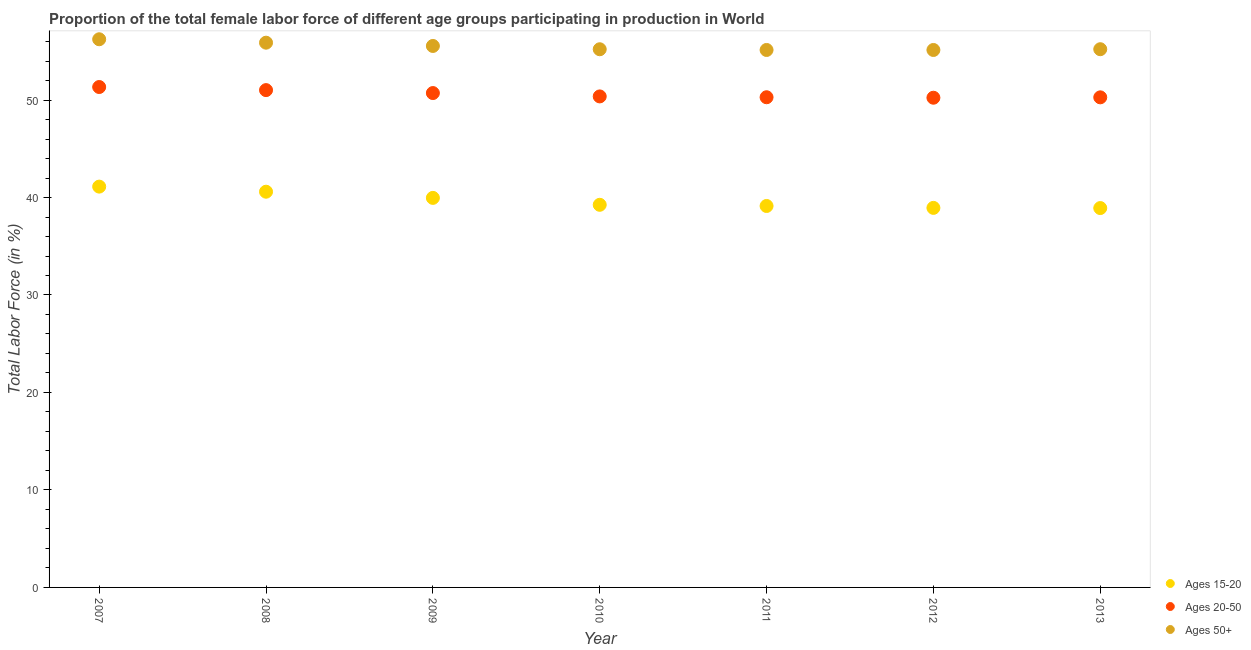How many different coloured dotlines are there?
Give a very brief answer. 3. What is the percentage of female labor force within the age group 20-50 in 2011?
Provide a succinct answer. 50.29. Across all years, what is the maximum percentage of female labor force within the age group 20-50?
Your answer should be very brief. 51.34. Across all years, what is the minimum percentage of female labor force within the age group 15-20?
Give a very brief answer. 38.92. What is the total percentage of female labor force above age 50 in the graph?
Give a very brief answer. 388.36. What is the difference between the percentage of female labor force within the age group 20-50 in 2007 and that in 2013?
Your response must be concise. 1.06. What is the difference between the percentage of female labor force within the age group 20-50 in 2011 and the percentage of female labor force above age 50 in 2008?
Keep it short and to the point. -5.6. What is the average percentage of female labor force within the age group 20-50 per year?
Provide a short and direct response. 50.61. In the year 2010, what is the difference between the percentage of female labor force within the age group 20-50 and percentage of female labor force above age 50?
Provide a short and direct response. -4.84. What is the ratio of the percentage of female labor force within the age group 15-20 in 2007 to that in 2011?
Your answer should be very brief. 1.05. What is the difference between the highest and the second highest percentage of female labor force above age 50?
Offer a very short reply. 0.35. What is the difference between the highest and the lowest percentage of female labor force above age 50?
Your answer should be very brief. 1.1. In how many years, is the percentage of female labor force above age 50 greater than the average percentage of female labor force above age 50 taken over all years?
Keep it short and to the point. 3. Is it the case that in every year, the sum of the percentage of female labor force within the age group 15-20 and percentage of female labor force within the age group 20-50 is greater than the percentage of female labor force above age 50?
Provide a succinct answer. Yes. Does the percentage of female labor force within the age group 15-20 monotonically increase over the years?
Offer a very short reply. No. Is the percentage of female labor force within the age group 20-50 strictly less than the percentage of female labor force above age 50 over the years?
Make the answer very short. Yes. How many years are there in the graph?
Ensure brevity in your answer.  7. What is the difference between two consecutive major ticks on the Y-axis?
Keep it short and to the point. 10. Where does the legend appear in the graph?
Your answer should be very brief. Bottom right. How many legend labels are there?
Your response must be concise. 3. What is the title of the graph?
Make the answer very short. Proportion of the total female labor force of different age groups participating in production in World. Does "Fuel" appear as one of the legend labels in the graph?
Provide a short and direct response. No. What is the label or title of the X-axis?
Your answer should be compact. Year. What is the Total Labor Force (in %) of Ages 15-20 in 2007?
Keep it short and to the point. 41.12. What is the Total Labor Force (in %) of Ages 20-50 in 2007?
Offer a terse response. 51.34. What is the Total Labor Force (in %) of Ages 50+ in 2007?
Keep it short and to the point. 56.23. What is the Total Labor Force (in %) of Ages 15-20 in 2008?
Ensure brevity in your answer.  40.59. What is the Total Labor Force (in %) in Ages 20-50 in 2008?
Offer a terse response. 51.02. What is the Total Labor Force (in %) in Ages 50+ in 2008?
Provide a succinct answer. 55.88. What is the Total Labor Force (in %) of Ages 15-20 in 2009?
Provide a succinct answer. 39.96. What is the Total Labor Force (in %) of Ages 20-50 in 2009?
Give a very brief answer. 50.72. What is the Total Labor Force (in %) in Ages 50+ in 2009?
Make the answer very short. 55.55. What is the Total Labor Force (in %) in Ages 15-20 in 2010?
Your answer should be compact. 39.25. What is the Total Labor Force (in %) of Ages 20-50 in 2010?
Provide a short and direct response. 50.37. What is the Total Labor Force (in %) in Ages 50+ in 2010?
Ensure brevity in your answer.  55.21. What is the Total Labor Force (in %) of Ages 15-20 in 2011?
Offer a very short reply. 39.13. What is the Total Labor Force (in %) of Ages 20-50 in 2011?
Offer a very short reply. 50.29. What is the Total Labor Force (in %) in Ages 50+ in 2011?
Provide a succinct answer. 55.14. What is the Total Labor Force (in %) in Ages 15-20 in 2012?
Provide a short and direct response. 38.94. What is the Total Labor Force (in %) of Ages 20-50 in 2012?
Offer a very short reply. 50.24. What is the Total Labor Force (in %) in Ages 50+ in 2012?
Offer a very short reply. 55.14. What is the Total Labor Force (in %) in Ages 15-20 in 2013?
Provide a short and direct response. 38.92. What is the Total Labor Force (in %) in Ages 20-50 in 2013?
Your answer should be very brief. 50.28. What is the Total Labor Force (in %) in Ages 50+ in 2013?
Give a very brief answer. 55.21. Across all years, what is the maximum Total Labor Force (in %) in Ages 15-20?
Give a very brief answer. 41.12. Across all years, what is the maximum Total Labor Force (in %) in Ages 20-50?
Offer a very short reply. 51.34. Across all years, what is the maximum Total Labor Force (in %) in Ages 50+?
Ensure brevity in your answer.  56.23. Across all years, what is the minimum Total Labor Force (in %) of Ages 15-20?
Keep it short and to the point. 38.92. Across all years, what is the minimum Total Labor Force (in %) of Ages 20-50?
Your answer should be compact. 50.24. Across all years, what is the minimum Total Labor Force (in %) in Ages 50+?
Keep it short and to the point. 55.14. What is the total Total Labor Force (in %) of Ages 15-20 in the graph?
Ensure brevity in your answer.  277.91. What is the total Total Labor Force (in %) in Ages 20-50 in the graph?
Give a very brief answer. 354.24. What is the total Total Labor Force (in %) of Ages 50+ in the graph?
Your answer should be very brief. 388.36. What is the difference between the Total Labor Force (in %) in Ages 15-20 in 2007 and that in 2008?
Your answer should be compact. 0.52. What is the difference between the Total Labor Force (in %) of Ages 20-50 in 2007 and that in 2008?
Offer a terse response. 0.32. What is the difference between the Total Labor Force (in %) in Ages 50+ in 2007 and that in 2008?
Offer a terse response. 0.35. What is the difference between the Total Labor Force (in %) in Ages 15-20 in 2007 and that in 2009?
Offer a very short reply. 1.16. What is the difference between the Total Labor Force (in %) of Ages 20-50 in 2007 and that in 2009?
Offer a very short reply. 0.62. What is the difference between the Total Labor Force (in %) in Ages 50+ in 2007 and that in 2009?
Keep it short and to the point. 0.69. What is the difference between the Total Labor Force (in %) of Ages 15-20 in 2007 and that in 2010?
Keep it short and to the point. 1.87. What is the difference between the Total Labor Force (in %) in Ages 20-50 in 2007 and that in 2010?
Provide a succinct answer. 0.96. What is the difference between the Total Labor Force (in %) of Ages 50+ in 2007 and that in 2010?
Make the answer very short. 1.02. What is the difference between the Total Labor Force (in %) in Ages 15-20 in 2007 and that in 2011?
Keep it short and to the point. 1.99. What is the difference between the Total Labor Force (in %) in Ages 20-50 in 2007 and that in 2011?
Provide a short and direct response. 1.05. What is the difference between the Total Labor Force (in %) in Ages 50+ in 2007 and that in 2011?
Keep it short and to the point. 1.1. What is the difference between the Total Labor Force (in %) in Ages 15-20 in 2007 and that in 2012?
Offer a very short reply. 2.18. What is the difference between the Total Labor Force (in %) of Ages 20-50 in 2007 and that in 2012?
Provide a short and direct response. 1.1. What is the difference between the Total Labor Force (in %) in Ages 50+ in 2007 and that in 2012?
Your answer should be very brief. 1.1. What is the difference between the Total Labor Force (in %) of Ages 15-20 in 2007 and that in 2013?
Make the answer very short. 2.2. What is the difference between the Total Labor Force (in %) in Ages 20-50 in 2007 and that in 2013?
Your answer should be very brief. 1.06. What is the difference between the Total Labor Force (in %) of Ages 50+ in 2007 and that in 2013?
Ensure brevity in your answer.  1.02. What is the difference between the Total Labor Force (in %) in Ages 15-20 in 2008 and that in 2009?
Give a very brief answer. 0.63. What is the difference between the Total Labor Force (in %) in Ages 20-50 in 2008 and that in 2009?
Your answer should be compact. 0.3. What is the difference between the Total Labor Force (in %) of Ages 50+ in 2008 and that in 2009?
Keep it short and to the point. 0.34. What is the difference between the Total Labor Force (in %) of Ages 15-20 in 2008 and that in 2010?
Provide a short and direct response. 1.34. What is the difference between the Total Labor Force (in %) of Ages 20-50 in 2008 and that in 2010?
Keep it short and to the point. 0.65. What is the difference between the Total Labor Force (in %) of Ages 50+ in 2008 and that in 2010?
Your response must be concise. 0.67. What is the difference between the Total Labor Force (in %) in Ages 15-20 in 2008 and that in 2011?
Make the answer very short. 1.46. What is the difference between the Total Labor Force (in %) in Ages 20-50 in 2008 and that in 2011?
Provide a short and direct response. 0.73. What is the difference between the Total Labor Force (in %) in Ages 50+ in 2008 and that in 2011?
Provide a short and direct response. 0.75. What is the difference between the Total Labor Force (in %) of Ages 15-20 in 2008 and that in 2012?
Your answer should be compact. 1.66. What is the difference between the Total Labor Force (in %) in Ages 20-50 in 2008 and that in 2012?
Offer a terse response. 0.78. What is the difference between the Total Labor Force (in %) of Ages 50+ in 2008 and that in 2012?
Provide a short and direct response. 0.75. What is the difference between the Total Labor Force (in %) in Ages 15-20 in 2008 and that in 2013?
Provide a succinct answer. 1.68. What is the difference between the Total Labor Force (in %) in Ages 20-50 in 2008 and that in 2013?
Your answer should be compact. 0.74. What is the difference between the Total Labor Force (in %) of Ages 50+ in 2008 and that in 2013?
Offer a terse response. 0.67. What is the difference between the Total Labor Force (in %) in Ages 15-20 in 2009 and that in 2010?
Keep it short and to the point. 0.71. What is the difference between the Total Labor Force (in %) in Ages 20-50 in 2009 and that in 2010?
Your answer should be compact. 0.34. What is the difference between the Total Labor Force (in %) in Ages 50+ in 2009 and that in 2010?
Your answer should be compact. 0.34. What is the difference between the Total Labor Force (in %) of Ages 15-20 in 2009 and that in 2011?
Your answer should be compact. 0.83. What is the difference between the Total Labor Force (in %) in Ages 20-50 in 2009 and that in 2011?
Offer a very short reply. 0.43. What is the difference between the Total Labor Force (in %) of Ages 50+ in 2009 and that in 2011?
Your response must be concise. 0.41. What is the difference between the Total Labor Force (in %) in Ages 15-20 in 2009 and that in 2012?
Offer a very short reply. 1.03. What is the difference between the Total Labor Force (in %) in Ages 20-50 in 2009 and that in 2012?
Offer a terse response. 0.48. What is the difference between the Total Labor Force (in %) in Ages 50+ in 2009 and that in 2012?
Your answer should be very brief. 0.41. What is the difference between the Total Labor Force (in %) in Ages 15-20 in 2009 and that in 2013?
Provide a short and direct response. 1.04. What is the difference between the Total Labor Force (in %) in Ages 20-50 in 2009 and that in 2013?
Keep it short and to the point. 0.44. What is the difference between the Total Labor Force (in %) of Ages 15-20 in 2010 and that in 2011?
Give a very brief answer. 0.12. What is the difference between the Total Labor Force (in %) in Ages 20-50 in 2010 and that in 2011?
Make the answer very short. 0.09. What is the difference between the Total Labor Force (in %) of Ages 50+ in 2010 and that in 2011?
Offer a very short reply. 0.07. What is the difference between the Total Labor Force (in %) in Ages 15-20 in 2010 and that in 2012?
Keep it short and to the point. 0.32. What is the difference between the Total Labor Force (in %) of Ages 20-50 in 2010 and that in 2012?
Your answer should be very brief. 0.13. What is the difference between the Total Labor Force (in %) of Ages 50+ in 2010 and that in 2012?
Offer a terse response. 0.07. What is the difference between the Total Labor Force (in %) of Ages 15-20 in 2010 and that in 2013?
Offer a very short reply. 0.33. What is the difference between the Total Labor Force (in %) of Ages 20-50 in 2010 and that in 2013?
Offer a very short reply. 0.09. What is the difference between the Total Labor Force (in %) in Ages 50+ in 2010 and that in 2013?
Make the answer very short. -0. What is the difference between the Total Labor Force (in %) in Ages 15-20 in 2011 and that in 2012?
Your response must be concise. 0.2. What is the difference between the Total Labor Force (in %) in Ages 20-50 in 2011 and that in 2012?
Provide a short and direct response. 0.05. What is the difference between the Total Labor Force (in %) in Ages 50+ in 2011 and that in 2012?
Your answer should be compact. 0. What is the difference between the Total Labor Force (in %) of Ages 15-20 in 2011 and that in 2013?
Offer a terse response. 0.21. What is the difference between the Total Labor Force (in %) in Ages 20-50 in 2011 and that in 2013?
Make the answer very short. 0.01. What is the difference between the Total Labor Force (in %) in Ages 50+ in 2011 and that in 2013?
Provide a short and direct response. -0.08. What is the difference between the Total Labor Force (in %) of Ages 15-20 in 2012 and that in 2013?
Your answer should be very brief. 0.02. What is the difference between the Total Labor Force (in %) in Ages 20-50 in 2012 and that in 2013?
Your answer should be compact. -0.04. What is the difference between the Total Labor Force (in %) in Ages 50+ in 2012 and that in 2013?
Ensure brevity in your answer.  -0.08. What is the difference between the Total Labor Force (in %) of Ages 15-20 in 2007 and the Total Labor Force (in %) of Ages 20-50 in 2008?
Provide a succinct answer. -9.9. What is the difference between the Total Labor Force (in %) in Ages 15-20 in 2007 and the Total Labor Force (in %) in Ages 50+ in 2008?
Give a very brief answer. -14.77. What is the difference between the Total Labor Force (in %) of Ages 20-50 in 2007 and the Total Labor Force (in %) of Ages 50+ in 2008?
Your response must be concise. -4.55. What is the difference between the Total Labor Force (in %) in Ages 15-20 in 2007 and the Total Labor Force (in %) in Ages 20-50 in 2009?
Offer a terse response. -9.6. What is the difference between the Total Labor Force (in %) of Ages 15-20 in 2007 and the Total Labor Force (in %) of Ages 50+ in 2009?
Provide a succinct answer. -14.43. What is the difference between the Total Labor Force (in %) of Ages 20-50 in 2007 and the Total Labor Force (in %) of Ages 50+ in 2009?
Provide a succinct answer. -4.21. What is the difference between the Total Labor Force (in %) of Ages 15-20 in 2007 and the Total Labor Force (in %) of Ages 20-50 in 2010?
Offer a very short reply. -9.25. What is the difference between the Total Labor Force (in %) in Ages 15-20 in 2007 and the Total Labor Force (in %) in Ages 50+ in 2010?
Keep it short and to the point. -14.09. What is the difference between the Total Labor Force (in %) in Ages 20-50 in 2007 and the Total Labor Force (in %) in Ages 50+ in 2010?
Provide a short and direct response. -3.87. What is the difference between the Total Labor Force (in %) in Ages 15-20 in 2007 and the Total Labor Force (in %) in Ages 20-50 in 2011?
Provide a short and direct response. -9.17. What is the difference between the Total Labor Force (in %) of Ages 15-20 in 2007 and the Total Labor Force (in %) of Ages 50+ in 2011?
Your answer should be compact. -14.02. What is the difference between the Total Labor Force (in %) of Ages 20-50 in 2007 and the Total Labor Force (in %) of Ages 50+ in 2011?
Provide a short and direct response. -3.8. What is the difference between the Total Labor Force (in %) in Ages 15-20 in 2007 and the Total Labor Force (in %) in Ages 20-50 in 2012?
Your answer should be very brief. -9.12. What is the difference between the Total Labor Force (in %) in Ages 15-20 in 2007 and the Total Labor Force (in %) in Ages 50+ in 2012?
Make the answer very short. -14.02. What is the difference between the Total Labor Force (in %) in Ages 20-50 in 2007 and the Total Labor Force (in %) in Ages 50+ in 2012?
Ensure brevity in your answer.  -3.8. What is the difference between the Total Labor Force (in %) of Ages 15-20 in 2007 and the Total Labor Force (in %) of Ages 20-50 in 2013?
Provide a short and direct response. -9.16. What is the difference between the Total Labor Force (in %) of Ages 15-20 in 2007 and the Total Labor Force (in %) of Ages 50+ in 2013?
Your answer should be compact. -14.1. What is the difference between the Total Labor Force (in %) of Ages 20-50 in 2007 and the Total Labor Force (in %) of Ages 50+ in 2013?
Provide a succinct answer. -3.88. What is the difference between the Total Labor Force (in %) in Ages 15-20 in 2008 and the Total Labor Force (in %) in Ages 20-50 in 2009?
Your response must be concise. -10.12. What is the difference between the Total Labor Force (in %) in Ages 15-20 in 2008 and the Total Labor Force (in %) in Ages 50+ in 2009?
Ensure brevity in your answer.  -14.95. What is the difference between the Total Labor Force (in %) in Ages 20-50 in 2008 and the Total Labor Force (in %) in Ages 50+ in 2009?
Keep it short and to the point. -4.53. What is the difference between the Total Labor Force (in %) of Ages 15-20 in 2008 and the Total Labor Force (in %) of Ages 20-50 in 2010?
Your answer should be very brief. -9.78. What is the difference between the Total Labor Force (in %) of Ages 15-20 in 2008 and the Total Labor Force (in %) of Ages 50+ in 2010?
Keep it short and to the point. -14.62. What is the difference between the Total Labor Force (in %) in Ages 20-50 in 2008 and the Total Labor Force (in %) in Ages 50+ in 2010?
Your response must be concise. -4.19. What is the difference between the Total Labor Force (in %) of Ages 15-20 in 2008 and the Total Labor Force (in %) of Ages 20-50 in 2011?
Keep it short and to the point. -9.69. What is the difference between the Total Labor Force (in %) in Ages 15-20 in 2008 and the Total Labor Force (in %) in Ages 50+ in 2011?
Make the answer very short. -14.54. What is the difference between the Total Labor Force (in %) of Ages 20-50 in 2008 and the Total Labor Force (in %) of Ages 50+ in 2011?
Ensure brevity in your answer.  -4.12. What is the difference between the Total Labor Force (in %) of Ages 15-20 in 2008 and the Total Labor Force (in %) of Ages 20-50 in 2012?
Provide a succinct answer. -9.64. What is the difference between the Total Labor Force (in %) of Ages 15-20 in 2008 and the Total Labor Force (in %) of Ages 50+ in 2012?
Keep it short and to the point. -14.54. What is the difference between the Total Labor Force (in %) of Ages 20-50 in 2008 and the Total Labor Force (in %) of Ages 50+ in 2012?
Provide a short and direct response. -4.12. What is the difference between the Total Labor Force (in %) of Ages 15-20 in 2008 and the Total Labor Force (in %) of Ages 20-50 in 2013?
Make the answer very short. -9.68. What is the difference between the Total Labor Force (in %) of Ages 15-20 in 2008 and the Total Labor Force (in %) of Ages 50+ in 2013?
Provide a short and direct response. -14.62. What is the difference between the Total Labor Force (in %) in Ages 20-50 in 2008 and the Total Labor Force (in %) in Ages 50+ in 2013?
Provide a succinct answer. -4.2. What is the difference between the Total Labor Force (in %) in Ages 15-20 in 2009 and the Total Labor Force (in %) in Ages 20-50 in 2010?
Your answer should be very brief. -10.41. What is the difference between the Total Labor Force (in %) in Ages 15-20 in 2009 and the Total Labor Force (in %) in Ages 50+ in 2010?
Make the answer very short. -15.25. What is the difference between the Total Labor Force (in %) in Ages 20-50 in 2009 and the Total Labor Force (in %) in Ages 50+ in 2010?
Offer a terse response. -4.49. What is the difference between the Total Labor Force (in %) in Ages 15-20 in 2009 and the Total Labor Force (in %) in Ages 20-50 in 2011?
Your answer should be compact. -10.32. What is the difference between the Total Labor Force (in %) in Ages 15-20 in 2009 and the Total Labor Force (in %) in Ages 50+ in 2011?
Your response must be concise. -15.17. What is the difference between the Total Labor Force (in %) of Ages 20-50 in 2009 and the Total Labor Force (in %) of Ages 50+ in 2011?
Offer a very short reply. -4.42. What is the difference between the Total Labor Force (in %) in Ages 15-20 in 2009 and the Total Labor Force (in %) in Ages 20-50 in 2012?
Make the answer very short. -10.28. What is the difference between the Total Labor Force (in %) of Ages 15-20 in 2009 and the Total Labor Force (in %) of Ages 50+ in 2012?
Your answer should be very brief. -15.17. What is the difference between the Total Labor Force (in %) of Ages 20-50 in 2009 and the Total Labor Force (in %) of Ages 50+ in 2012?
Your response must be concise. -4.42. What is the difference between the Total Labor Force (in %) in Ages 15-20 in 2009 and the Total Labor Force (in %) in Ages 20-50 in 2013?
Offer a terse response. -10.31. What is the difference between the Total Labor Force (in %) of Ages 15-20 in 2009 and the Total Labor Force (in %) of Ages 50+ in 2013?
Keep it short and to the point. -15.25. What is the difference between the Total Labor Force (in %) in Ages 20-50 in 2009 and the Total Labor Force (in %) in Ages 50+ in 2013?
Make the answer very short. -4.5. What is the difference between the Total Labor Force (in %) of Ages 15-20 in 2010 and the Total Labor Force (in %) of Ages 20-50 in 2011?
Keep it short and to the point. -11.03. What is the difference between the Total Labor Force (in %) in Ages 15-20 in 2010 and the Total Labor Force (in %) in Ages 50+ in 2011?
Your answer should be compact. -15.88. What is the difference between the Total Labor Force (in %) in Ages 20-50 in 2010 and the Total Labor Force (in %) in Ages 50+ in 2011?
Offer a terse response. -4.76. What is the difference between the Total Labor Force (in %) of Ages 15-20 in 2010 and the Total Labor Force (in %) of Ages 20-50 in 2012?
Offer a terse response. -10.98. What is the difference between the Total Labor Force (in %) in Ages 15-20 in 2010 and the Total Labor Force (in %) in Ages 50+ in 2012?
Offer a very short reply. -15.88. What is the difference between the Total Labor Force (in %) in Ages 20-50 in 2010 and the Total Labor Force (in %) in Ages 50+ in 2012?
Your answer should be very brief. -4.76. What is the difference between the Total Labor Force (in %) of Ages 15-20 in 2010 and the Total Labor Force (in %) of Ages 20-50 in 2013?
Your answer should be very brief. -11.02. What is the difference between the Total Labor Force (in %) of Ages 15-20 in 2010 and the Total Labor Force (in %) of Ages 50+ in 2013?
Provide a short and direct response. -15.96. What is the difference between the Total Labor Force (in %) in Ages 20-50 in 2010 and the Total Labor Force (in %) in Ages 50+ in 2013?
Ensure brevity in your answer.  -4.84. What is the difference between the Total Labor Force (in %) of Ages 15-20 in 2011 and the Total Labor Force (in %) of Ages 20-50 in 2012?
Your answer should be very brief. -11.11. What is the difference between the Total Labor Force (in %) in Ages 15-20 in 2011 and the Total Labor Force (in %) in Ages 50+ in 2012?
Ensure brevity in your answer.  -16. What is the difference between the Total Labor Force (in %) of Ages 20-50 in 2011 and the Total Labor Force (in %) of Ages 50+ in 2012?
Your answer should be very brief. -4.85. What is the difference between the Total Labor Force (in %) in Ages 15-20 in 2011 and the Total Labor Force (in %) in Ages 20-50 in 2013?
Provide a short and direct response. -11.15. What is the difference between the Total Labor Force (in %) of Ages 15-20 in 2011 and the Total Labor Force (in %) of Ages 50+ in 2013?
Offer a very short reply. -16.08. What is the difference between the Total Labor Force (in %) of Ages 20-50 in 2011 and the Total Labor Force (in %) of Ages 50+ in 2013?
Give a very brief answer. -4.93. What is the difference between the Total Labor Force (in %) in Ages 15-20 in 2012 and the Total Labor Force (in %) in Ages 20-50 in 2013?
Your answer should be compact. -11.34. What is the difference between the Total Labor Force (in %) of Ages 15-20 in 2012 and the Total Labor Force (in %) of Ages 50+ in 2013?
Offer a very short reply. -16.28. What is the difference between the Total Labor Force (in %) of Ages 20-50 in 2012 and the Total Labor Force (in %) of Ages 50+ in 2013?
Make the answer very short. -4.98. What is the average Total Labor Force (in %) of Ages 15-20 per year?
Provide a succinct answer. 39.7. What is the average Total Labor Force (in %) of Ages 20-50 per year?
Your response must be concise. 50.61. What is the average Total Labor Force (in %) in Ages 50+ per year?
Make the answer very short. 55.48. In the year 2007, what is the difference between the Total Labor Force (in %) of Ages 15-20 and Total Labor Force (in %) of Ages 20-50?
Your response must be concise. -10.22. In the year 2007, what is the difference between the Total Labor Force (in %) in Ages 15-20 and Total Labor Force (in %) in Ages 50+?
Your answer should be very brief. -15.12. In the year 2007, what is the difference between the Total Labor Force (in %) in Ages 20-50 and Total Labor Force (in %) in Ages 50+?
Your answer should be compact. -4.9. In the year 2008, what is the difference between the Total Labor Force (in %) in Ages 15-20 and Total Labor Force (in %) in Ages 20-50?
Provide a short and direct response. -10.42. In the year 2008, what is the difference between the Total Labor Force (in %) of Ages 15-20 and Total Labor Force (in %) of Ages 50+?
Make the answer very short. -15.29. In the year 2008, what is the difference between the Total Labor Force (in %) in Ages 20-50 and Total Labor Force (in %) in Ages 50+?
Your response must be concise. -4.87. In the year 2009, what is the difference between the Total Labor Force (in %) of Ages 15-20 and Total Labor Force (in %) of Ages 20-50?
Ensure brevity in your answer.  -10.75. In the year 2009, what is the difference between the Total Labor Force (in %) of Ages 15-20 and Total Labor Force (in %) of Ages 50+?
Give a very brief answer. -15.59. In the year 2009, what is the difference between the Total Labor Force (in %) of Ages 20-50 and Total Labor Force (in %) of Ages 50+?
Make the answer very short. -4.83. In the year 2010, what is the difference between the Total Labor Force (in %) in Ages 15-20 and Total Labor Force (in %) in Ages 20-50?
Offer a very short reply. -11.12. In the year 2010, what is the difference between the Total Labor Force (in %) of Ages 15-20 and Total Labor Force (in %) of Ages 50+?
Provide a succinct answer. -15.96. In the year 2010, what is the difference between the Total Labor Force (in %) of Ages 20-50 and Total Labor Force (in %) of Ages 50+?
Provide a succinct answer. -4.84. In the year 2011, what is the difference between the Total Labor Force (in %) of Ages 15-20 and Total Labor Force (in %) of Ages 20-50?
Keep it short and to the point. -11.15. In the year 2011, what is the difference between the Total Labor Force (in %) in Ages 15-20 and Total Labor Force (in %) in Ages 50+?
Ensure brevity in your answer.  -16. In the year 2011, what is the difference between the Total Labor Force (in %) of Ages 20-50 and Total Labor Force (in %) of Ages 50+?
Keep it short and to the point. -4.85. In the year 2012, what is the difference between the Total Labor Force (in %) in Ages 15-20 and Total Labor Force (in %) in Ages 20-50?
Provide a short and direct response. -11.3. In the year 2012, what is the difference between the Total Labor Force (in %) in Ages 15-20 and Total Labor Force (in %) in Ages 50+?
Your answer should be compact. -16.2. In the year 2012, what is the difference between the Total Labor Force (in %) in Ages 20-50 and Total Labor Force (in %) in Ages 50+?
Your response must be concise. -4.9. In the year 2013, what is the difference between the Total Labor Force (in %) in Ages 15-20 and Total Labor Force (in %) in Ages 20-50?
Your response must be concise. -11.36. In the year 2013, what is the difference between the Total Labor Force (in %) of Ages 15-20 and Total Labor Force (in %) of Ages 50+?
Offer a terse response. -16.3. In the year 2013, what is the difference between the Total Labor Force (in %) of Ages 20-50 and Total Labor Force (in %) of Ages 50+?
Your answer should be compact. -4.94. What is the ratio of the Total Labor Force (in %) in Ages 15-20 in 2007 to that in 2008?
Ensure brevity in your answer.  1.01. What is the ratio of the Total Labor Force (in %) in Ages 50+ in 2007 to that in 2008?
Offer a very short reply. 1.01. What is the ratio of the Total Labor Force (in %) of Ages 15-20 in 2007 to that in 2009?
Your response must be concise. 1.03. What is the ratio of the Total Labor Force (in %) of Ages 20-50 in 2007 to that in 2009?
Provide a succinct answer. 1.01. What is the ratio of the Total Labor Force (in %) of Ages 50+ in 2007 to that in 2009?
Give a very brief answer. 1.01. What is the ratio of the Total Labor Force (in %) in Ages 15-20 in 2007 to that in 2010?
Your answer should be very brief. 1.05. What is the ratio of the Total Labor Force (in %) of Ages 20-50 in 2007 to that in 2010?
Your response must be concise. 1.02. What is the ratio of the Total Labor Force (in %) in Ages 50+ in 2007 to that in 2010?
Your answer should be very brief. 1.02. What is the ratio of the Total Labor Force (in %) in Ages 15-20 in 2007 to that in 2011?
Give a very brief answer. 1.05. What is the ratio of the Total Labor Force (in %) in Ages 20-50 in 2007 to that in 2011?
Make the answer very short. 1.02. What is the ratio of the Total Labor Force (in %) in Ages 50+ in 2007 to that in 2011?
Provide a short and direct response. 1.02. What is the ratio of the Total Labor Force (in %) in Ages 15-20 in 2007 to that in 2012?
Give a very brief answer. 1.06. What is the ratio of the Total Labor Force (in %) of Ages 20-50 in 2007 to that in 2012?
Your answer should be compact. 1.02. What is the ratio of the Total Labor Force (in %) in Ages 50+ in 2007 to that in 2012?
Your answer should be very brief. 1.02. What is the ratio of the Total Labor Force (in %) of Ages 15-20 in 2007 to that in 2013?
Your answer should be very brief. 1.06. What is the ratio of the Total Labor Force (in %) of Ages 20-50 in 2007 to that in 2013?
Keep it short and to the point. 1.02. What is the ratio of the Total Labor Force (in %) in Ages 50+ in 2007 to that in 2013?
Provide a succinct answer. 1.02. What is the ratio of the Total Labor Force (in %) of Ages 15-20 in 2008 to that in 2009?
Give a very brief answer. 1.02. What is the ratio of the Total Labor Force (in %) of Ages 15-20 in 2008 to that in 2010?
Your answer should be compact. 1.03. What is the ratio of the Total Labor Force (in %) in Ages 20-50 in 2008 to that in 2010?
Provide a succinct answer. 1.01. What is the ratio of the Total Labor Force (in %) of Ages 50+ in 2008 to that in 2010?
Ensure brevity in your answer.  1.01. What is the ratio of the Total Labor Force (in %) in Ages 15-20 in 2008 to that in 2011?
Your answer should be very brief. 1.04. What is the ratio of the Total Labor Force (in %) in Ages 20-50 in 2008 to that in 2011?
Your answer should be compact. 1.01. What is the ratio of the Total Labor Force (in %) in Ages 50+ in 2008 to that in 2011?
Give a very brief answer. 1.01. What is the ratio of the Total Labor Force (in %) of Ages 15-20 in 2008 to that in 2012?
Make the answer very short. 1.04. What is the ratio of the Total Labor Force (in %) in Ages 20-50 in 2008 to that in 2012?
Your answer should be very brief. 1.02. What is the ratio of the Total Labor Force (in %) of Ages 50+ in 2008 to that in 2012?
Your answer should be compact. 1.01. What is the ratio of the Total Labor Force (in %) of Ages 15-20 in 2008 to that in 2013?
Give a very brief answer. 1.04. What is the ratio of the Total Labor Force (in %) of Ages 20-50 in 2008 to that in 2013?
Provide a short and direct response. 1.01. What is the ratio of the Total Labor Force (in %) of Ages 50+ in 2008 to that in 2013?
Give a very brief answer. 1.01. What is the ratio of the Total Labor Force (in %) in Ages 15-20 in 2009 to that in 2010?
Your answer should be very brief. 1.02. What is the ratio of the Total Labor Force (in %) in Ages 20-50 in 2009 to that in 2010?
Keep it short and to the point. 1.01. What is the ratio of the Total Labor Force (in %) of Ages 15-20 in 2009 to that in 2011?
Give a very brief answer. 1.02. What is the ratio of the Total Labor Force (in %) in Ages 20-50 in 2009 to that in 2011?
Your answer should be very brief. 1.01. What is the ratio of the Total Labor Force (in %) of Ages 50+ in 2009 to that in 2011?
Provide a succinct answer. 1.01. What is the ratio of the Total Labor Force (in %) in Ages 15-20 in 2009 to that in 2012?
Give a very brief answer. 1.03. What is the ratio of the Total Labor Force (in %) in Ages 20-50 in 2009 to that in 2012?
Make the answer very short. 1.01. What is the ratio of the Total Labor Force (in %) of Ages 50+ in 2009 to that in 2012?
Your answer should be very brief. 1.01. What is the ratio of the Total Labor Force (in %) in Ages 15-20 in 2009 to that in 2013?
Keep it short and to the point. 1.03. What is the ratio of the Total Labor Force (in %) of Ages 20-50 in 2009 to that in 2013?
Your answer should be compact. 1.01. What is the ratio of the Total Labor Force (in %) of Ages 20-50 in 2010 to that in 2011?
Offer a terse response. 1. What is the ratio of the Total Labor Force (in %) of Ages 50+ in 2010 to that in 2011?
Keep it short and to the point. 1. What is the ratio of the Total Labor Force (in %) of Ages 15-20 in 2010 to that in 2012?
Give a very brief answer. 1.01. What is the ratio of the Total Labor Force (in %) of Ages 20-50 in 2010 to that in 2012?
Ensure brevity in your answer.  1. What is the ratio of the Total Labor Force (in %) in Ages 50+ in 2010 to that in 2012?
Your response must be concise. 1. What is the ratio of the Total Labor Force (in %) of Ages 15-20 in 2010 to that in 2013?
Keep it short and to the point. 1.01. What is the ratio of the Total Labor Force (in %) in Ages 20-50 in 2010 to that in 2013?
Your answer should be compact. 1. What is the ratio of the Total Labor Force (in %) in Ages 15-20 in 2011 to that in 2012?
Give a very brief answer. 1. What is the ratio of the Total Labor Force (in %) of Ages 20-50 in 2011 to that in 2012?
Offer a very short reply. 1. What is the ratio of the Total Labor Force (in %) in Ages 50+ in 2011 to that in 2012?
Offer a very short reply. 1. What is the ratio of the Total Labor Force (in %) in Ages 15-20 in 2011 to that in 2013?
Offer a very short reply. 1.01. What is the ratio of the Total Labor Force (in %) in Ages 15-20 in 2012 to that in 2013?
Your answer should be very brief. 1. What is the difference between the highest and the second highest Total Labor Force (in %) of Ages 15-20?
Give a very brief answer. 0.52. What is the difference between the highest and the second highest Total Labor Force (in %) in Ages 20-50?
Offer a terse response. 0.32. What is the difference between the highest and the second highest Total Labor Force (in %) in Ages 50+?
Give a very brief answer. 0.35. What is the difference between the highest and the lowest Total Labor Force (in %) in Ages 15-20?
Give a very brief answer. 2.2. What is the difference between the highest and the lowest Total Labor Force (in %) of Ages 20-50?
Ensure brevity in your answer.  1.1. What is the difference between the highest and the lowest Total Labor Force (in %) in Ages 50+?
Your response must be concise. 1.1. 